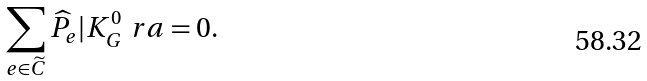<formula> <loc_0><loc_0><loc_500><loc_500>\sum _ { e \in { \widetilde { C } } } \widehat { P } _ { e } | K ^ { 0 } _ { G } \ r a = 0 .</formula> 